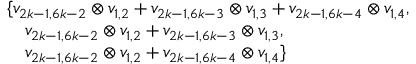Convert formula to latex. <formula><loc_0><loc_0><loc_500><loc_500>\begin{array} { r l } & { \{ v _ { 2 k - 1 , 6 k - 2 } \otimes v _ { 1 , 2 } + v _ { 2 k - 1 , 6 k - 3 } \otimes v _ { 1 , 3 } + v _ { 2 k - 1 , 6 k - 4 } \otimes v _ { 1 , 4 } , } \\ & { \quad v _ { 2 k - 1 , 6 k - 2 } \otimes v _ { 1 , 2 } + v _ { 2 k - 1 , 6 k - 3 } \otimes v _ { 1 , 3 } , } \\ & { \quad v _ { 2 k - 1 , 6 k - 2 } \otimes v _ { 1 , 2 } + v _ { 2 k - 1 , 6 k - 4 } \otimes v _ { 1 , 4 } \} } \end{array}</formula> 